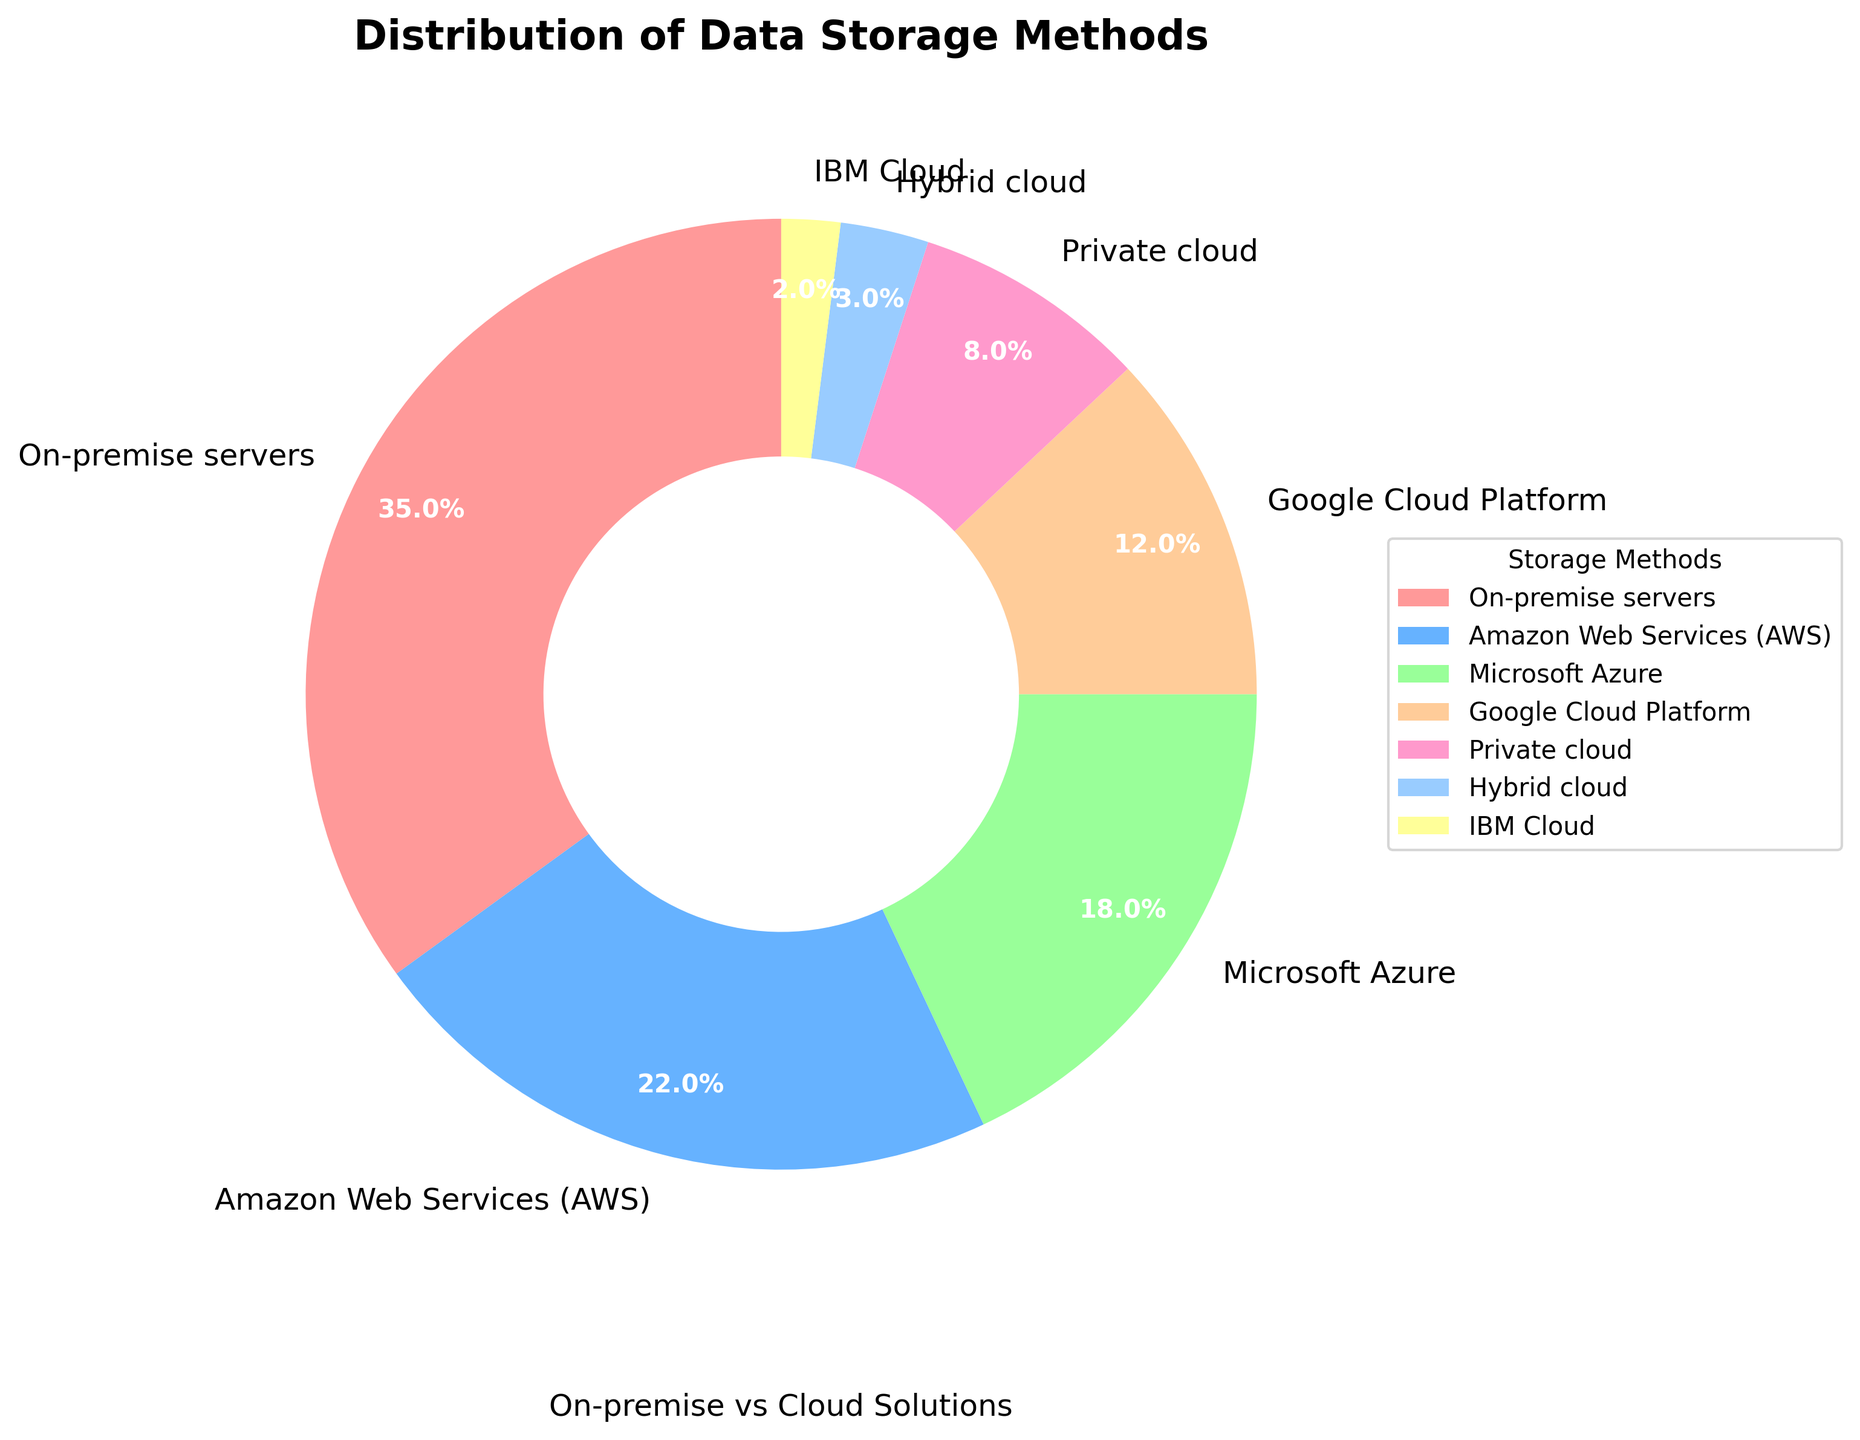What's the total percentage of cloud-based storage methods (AWS, Azure, Google Cloud Platform, Private cloud, Hybrid cloud, IBM Cloud) used? Sum the percentages of Amazon Web Services (AWS), Microsoft Azure, Google Cloud Platform, Private cloud, Hybrid cloud, and IBM Cloud: 22 + 18 + 12 + 8 + 3 + 2 = 65%
Answer: 65% Which storage method has the highest usage percentage? Identify the storage method with the largest percentage value. On-premise servers has the highest percentage at 35%.
Answer: On-premise servers How does the usage percentage of AWS compare to Azure? Compare the percentages: AWS is 22% and Azure is 18%. AWS has a higher usage percentage than Azure.
Answer: AWS has a higher usage than Azure What is the percentage difference between on-premise servers and hybrid cloud? Subtract the hybrid cloud percentage from the on-premise servers percentage: 35 - 3 = 32%
Answer: 32% Which two storage methods have the smallest usage percentages and what are they? Identify the two smallest percentages: Hybrid Cloud (3%) and IBM Cloud (2%).
Answer: Hybrid cloud and IBM Cloud Do all cloud-based storage methods combined surpass the usage of on-premise servers? The combined percentage of cloud-based methods is 65%, which surpasses the 35% of on-premise servers.
Answer: Yes What percentage of businesses use private cloud storage? Identify the percentage associated with Private cloud. It is 8%.
Answer: 8% Which storage method is represented by the light blue color in the chart? Identify the storage method with the light blue color, which corresponds to Microsoft Azure.
Answer: Microsoft Azure What is the ratio of on-premise to AWS usage? Calculate the ratio by dividing the on-premise percentage by the AWS percentage: 35 / 22 ≈ 1.59
Answer: 1.59 By how much does Google Cloud Platform's usage exceed IBM Cloud's usage in percentage points? Subtract the IBM Cloud percentage from Google Cloud Platform percentage: 12 - 2 = 10%
Answer: 10% 